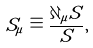<formula> <loc_0><loc_0><loc_500><loc_500>S _ { \mu } \equiv \frac { \partial _ { \mu } S } { S } ,</formula> 